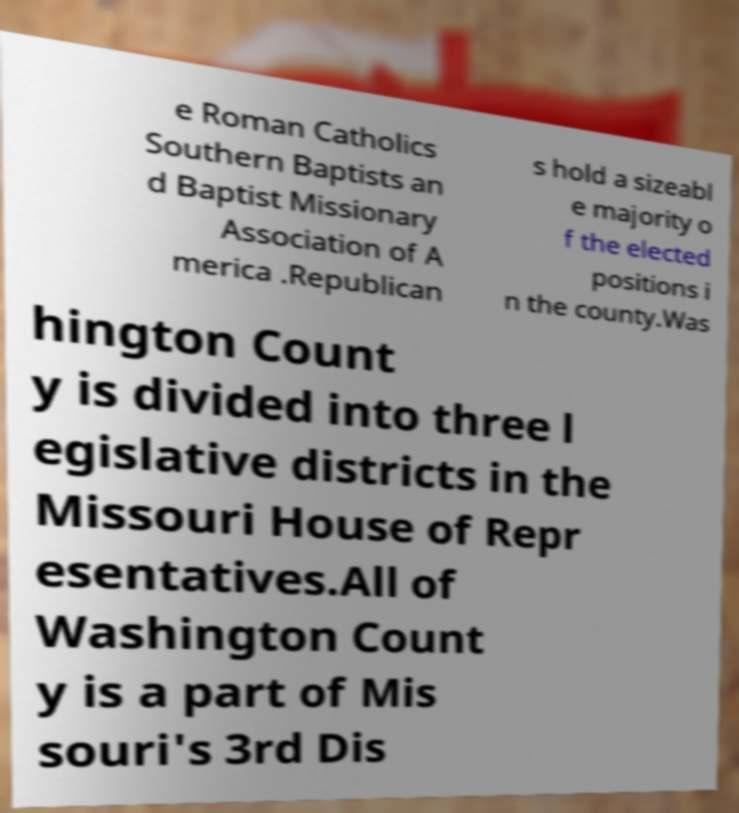Could you extract and type out the text from this image? e Roman Catholics Southern Baptists an d Baptist Missionary Association of A merica .Republican s hold a sizeabl e majority o f the elected positions i n the county.Was hington Count y is divided into three l egislative districts in the Missouri House of Repr esentatives.All of Washington Count y is a part of Mis souri's 3rd Dis 